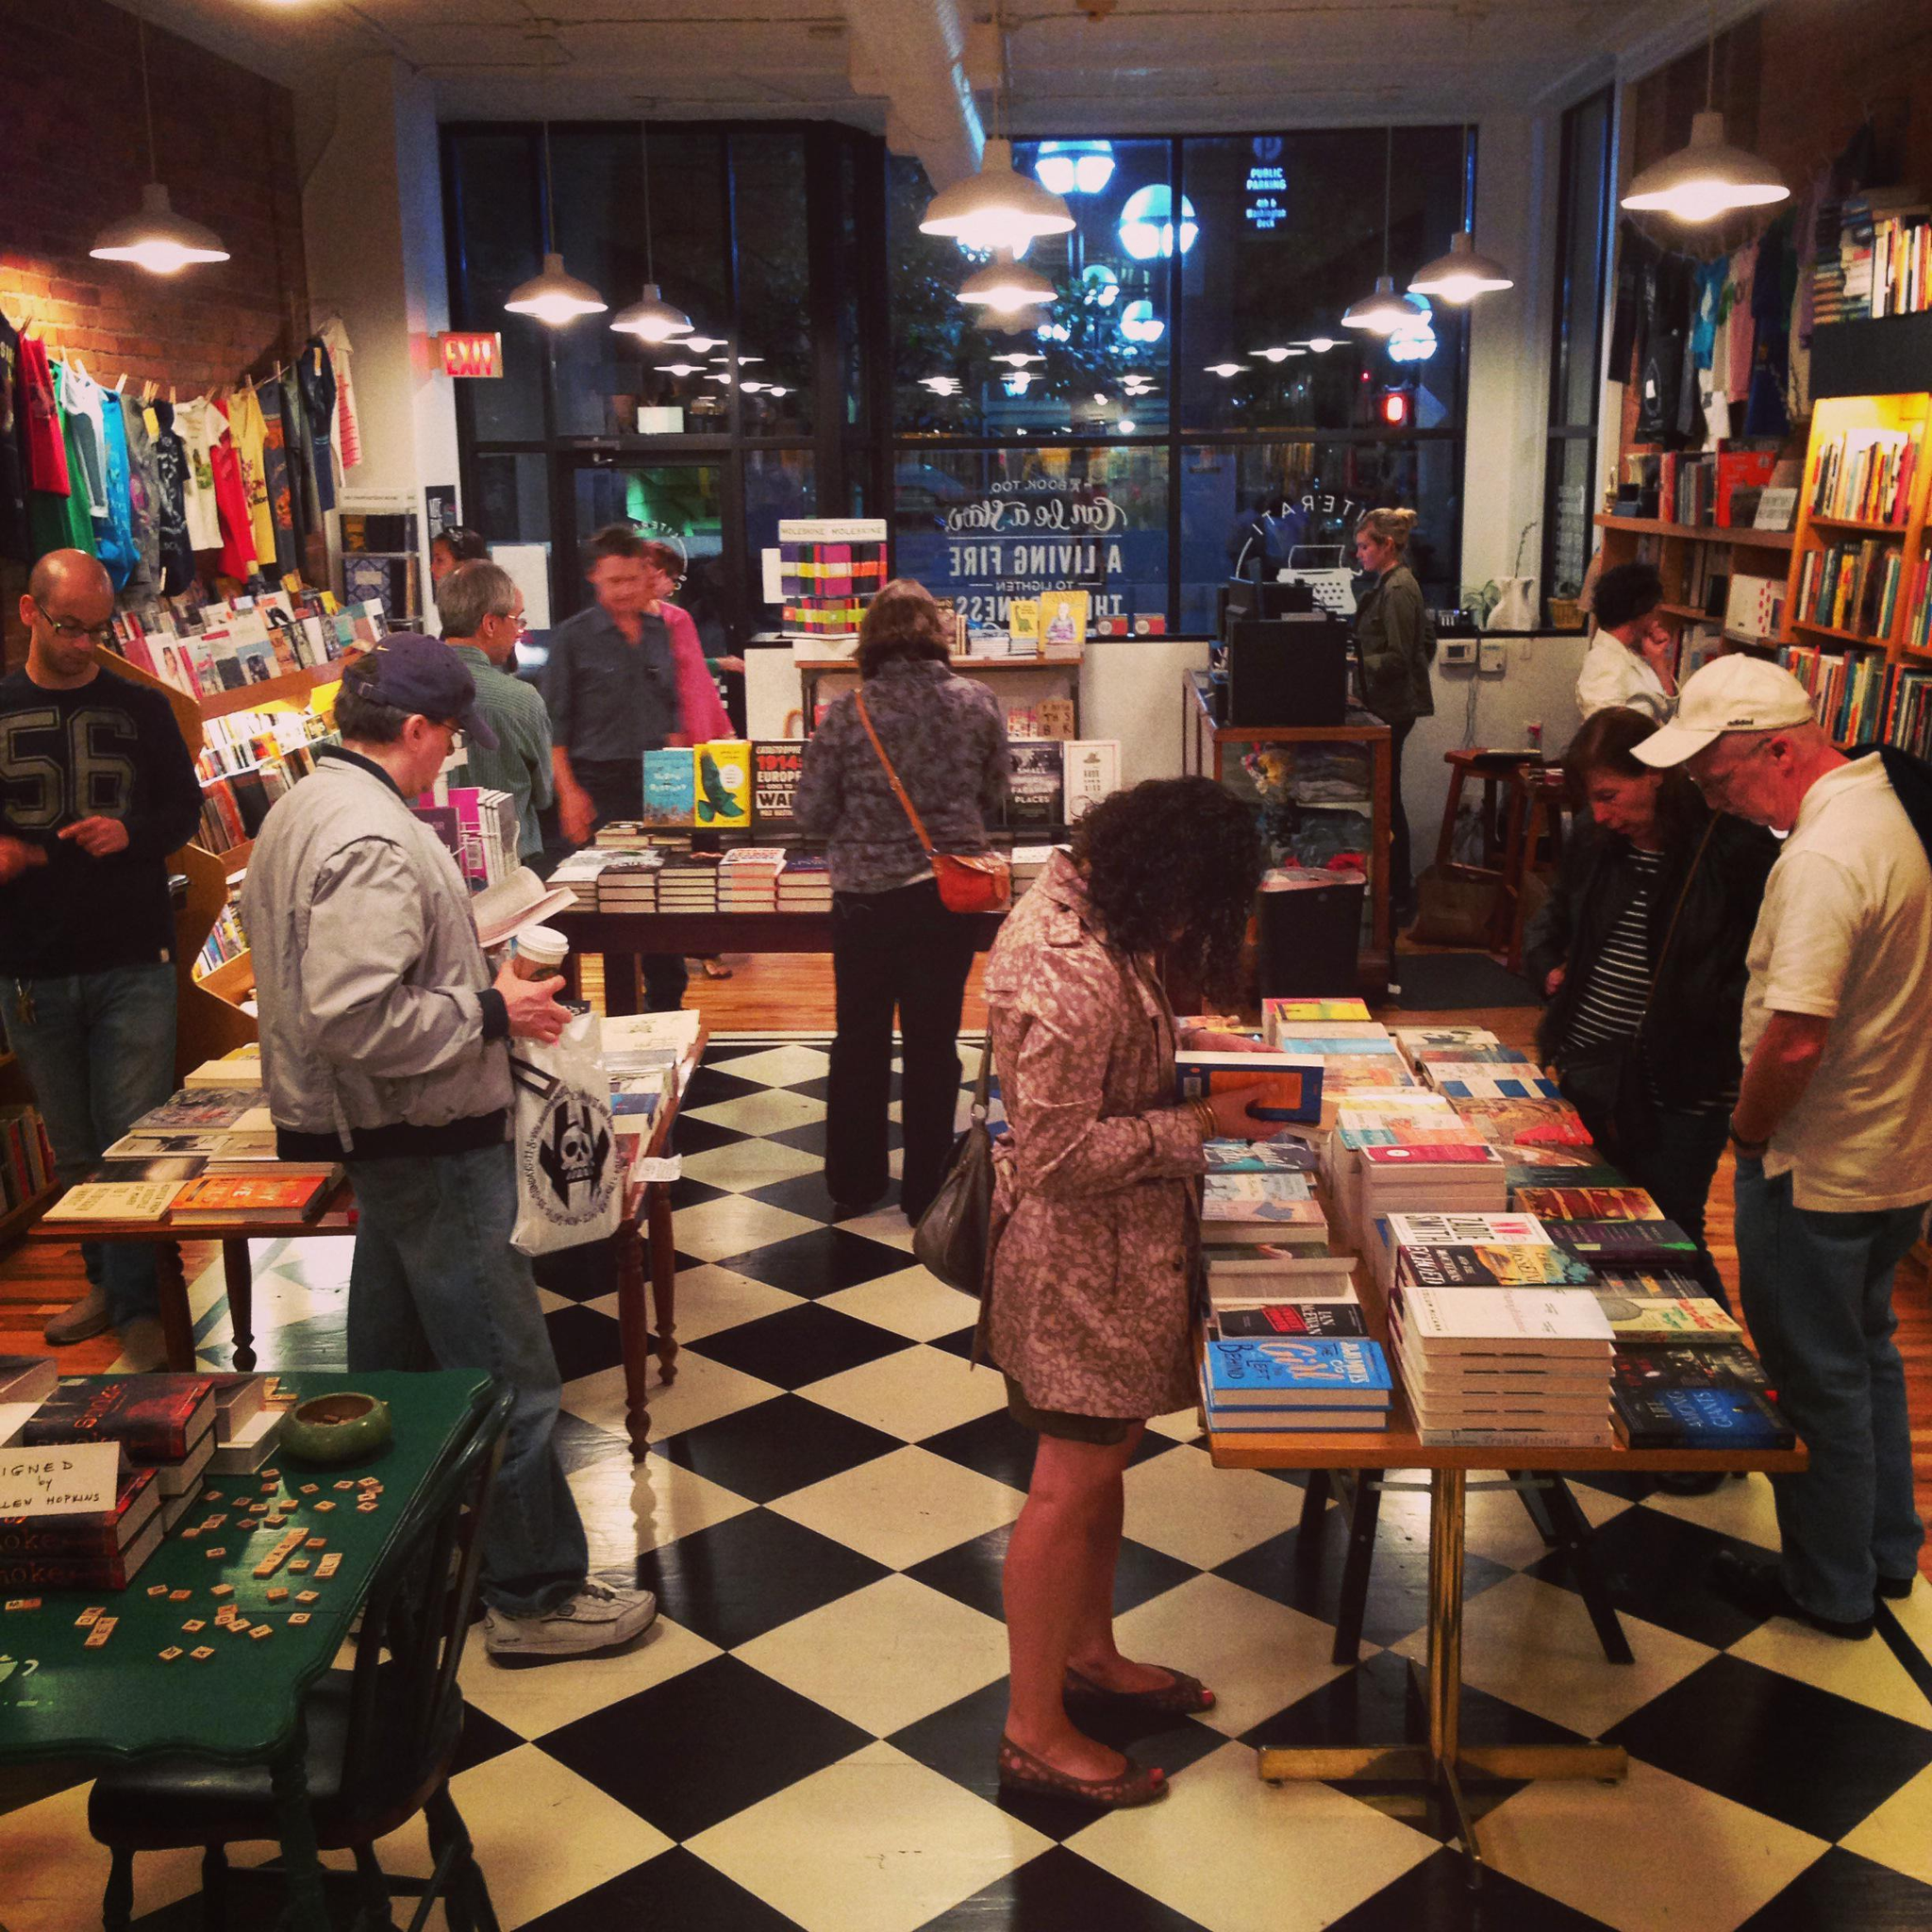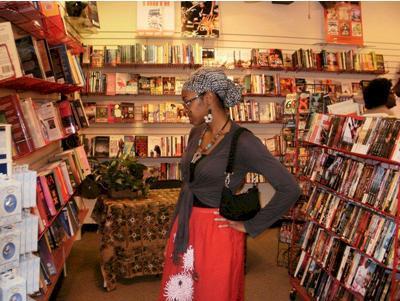The first image is the image on the left, the second image is the image on the right. For the images shown, is this caption "The left image shows people standing on the left and right of a counter, with heads bent toward each other." true? Answer yes or no. Yes. 